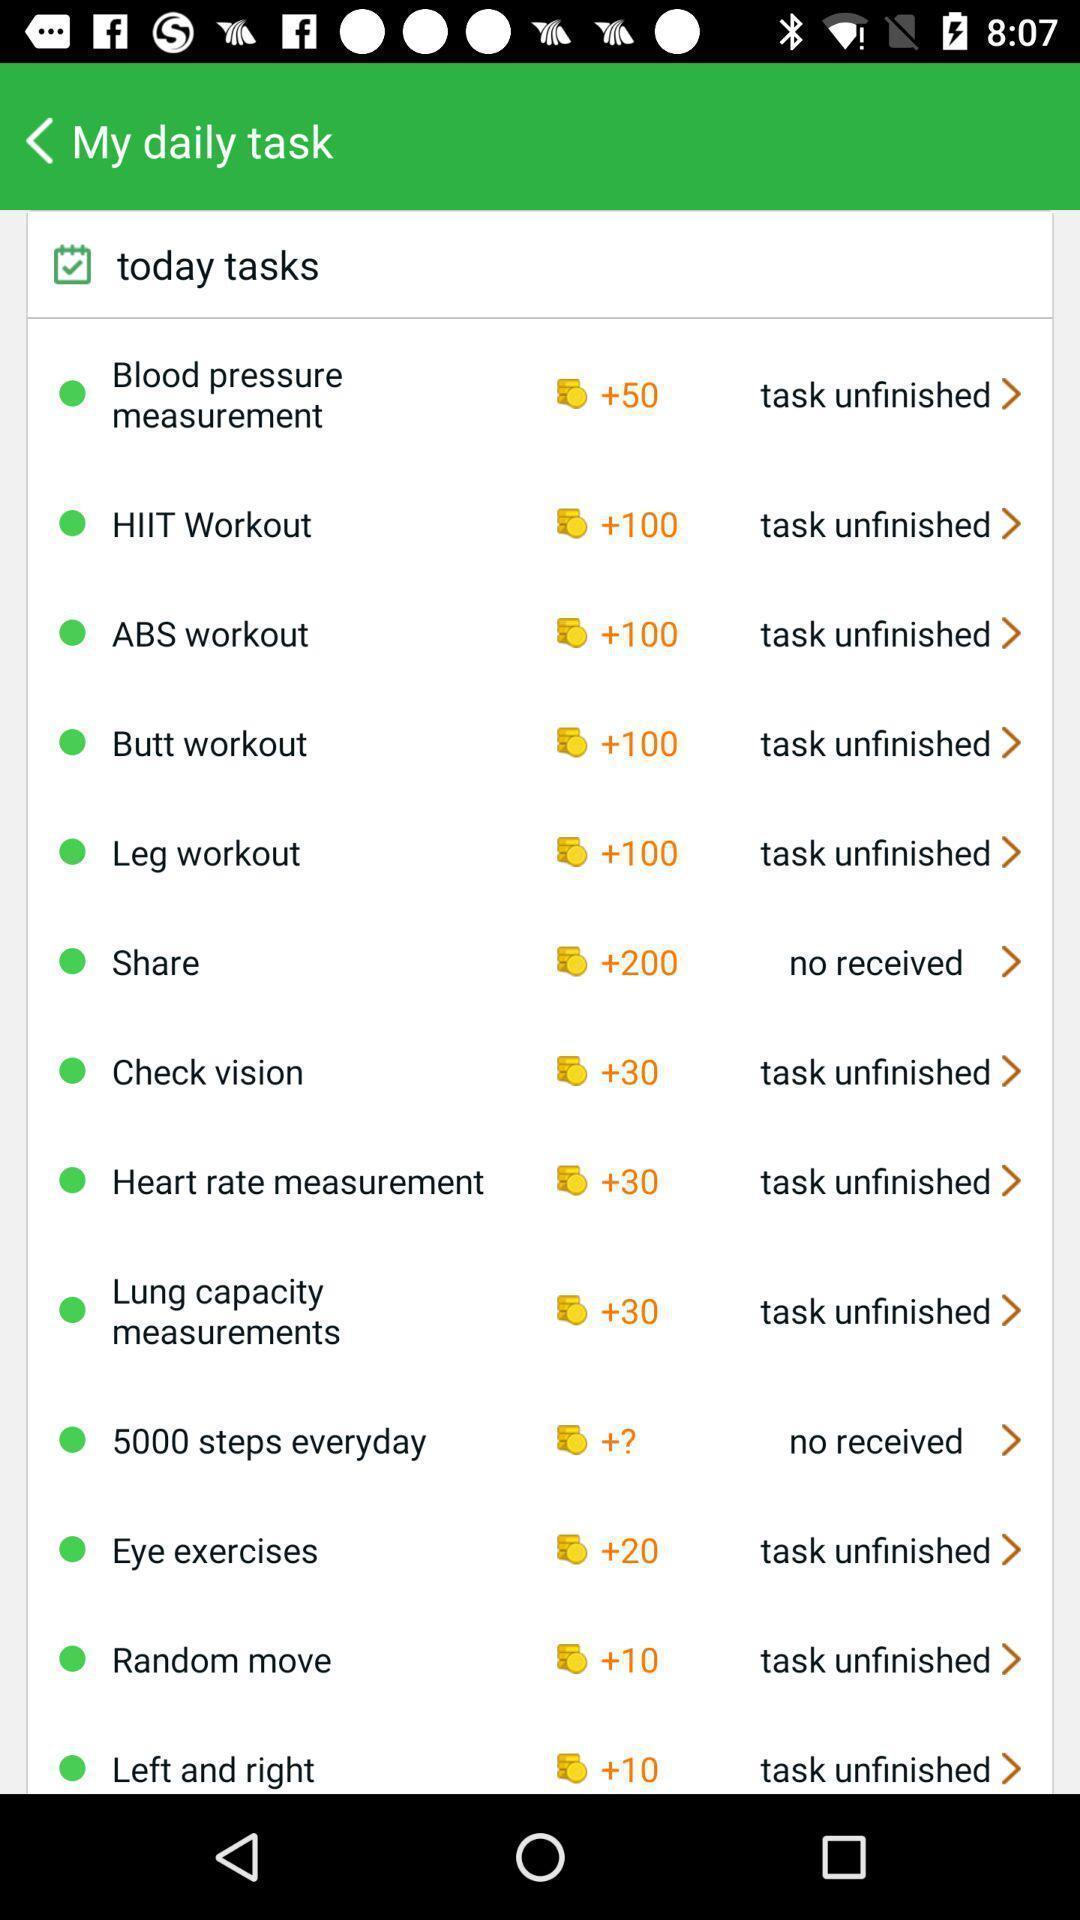Give me a summary of this screen capture. Task list in a health app. 